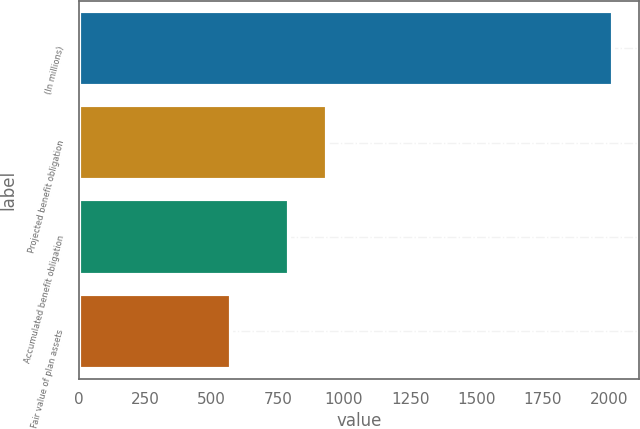Convert chart. <chart><loc_0><loc_0><loc_500><loc_500><bar_chart><fcel>(In millions)<fcel>Projected benefit obligation<fcel>Accumulated benefit obligation<fcel>Fair value of plan assets<nl><fcel>2014<fcel>937<fcel>793<fcel>574<nl></chart> 